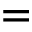Convert formula to latex. <formula><loc_0><loc_0><loc_500><loc_500>=</formula> 